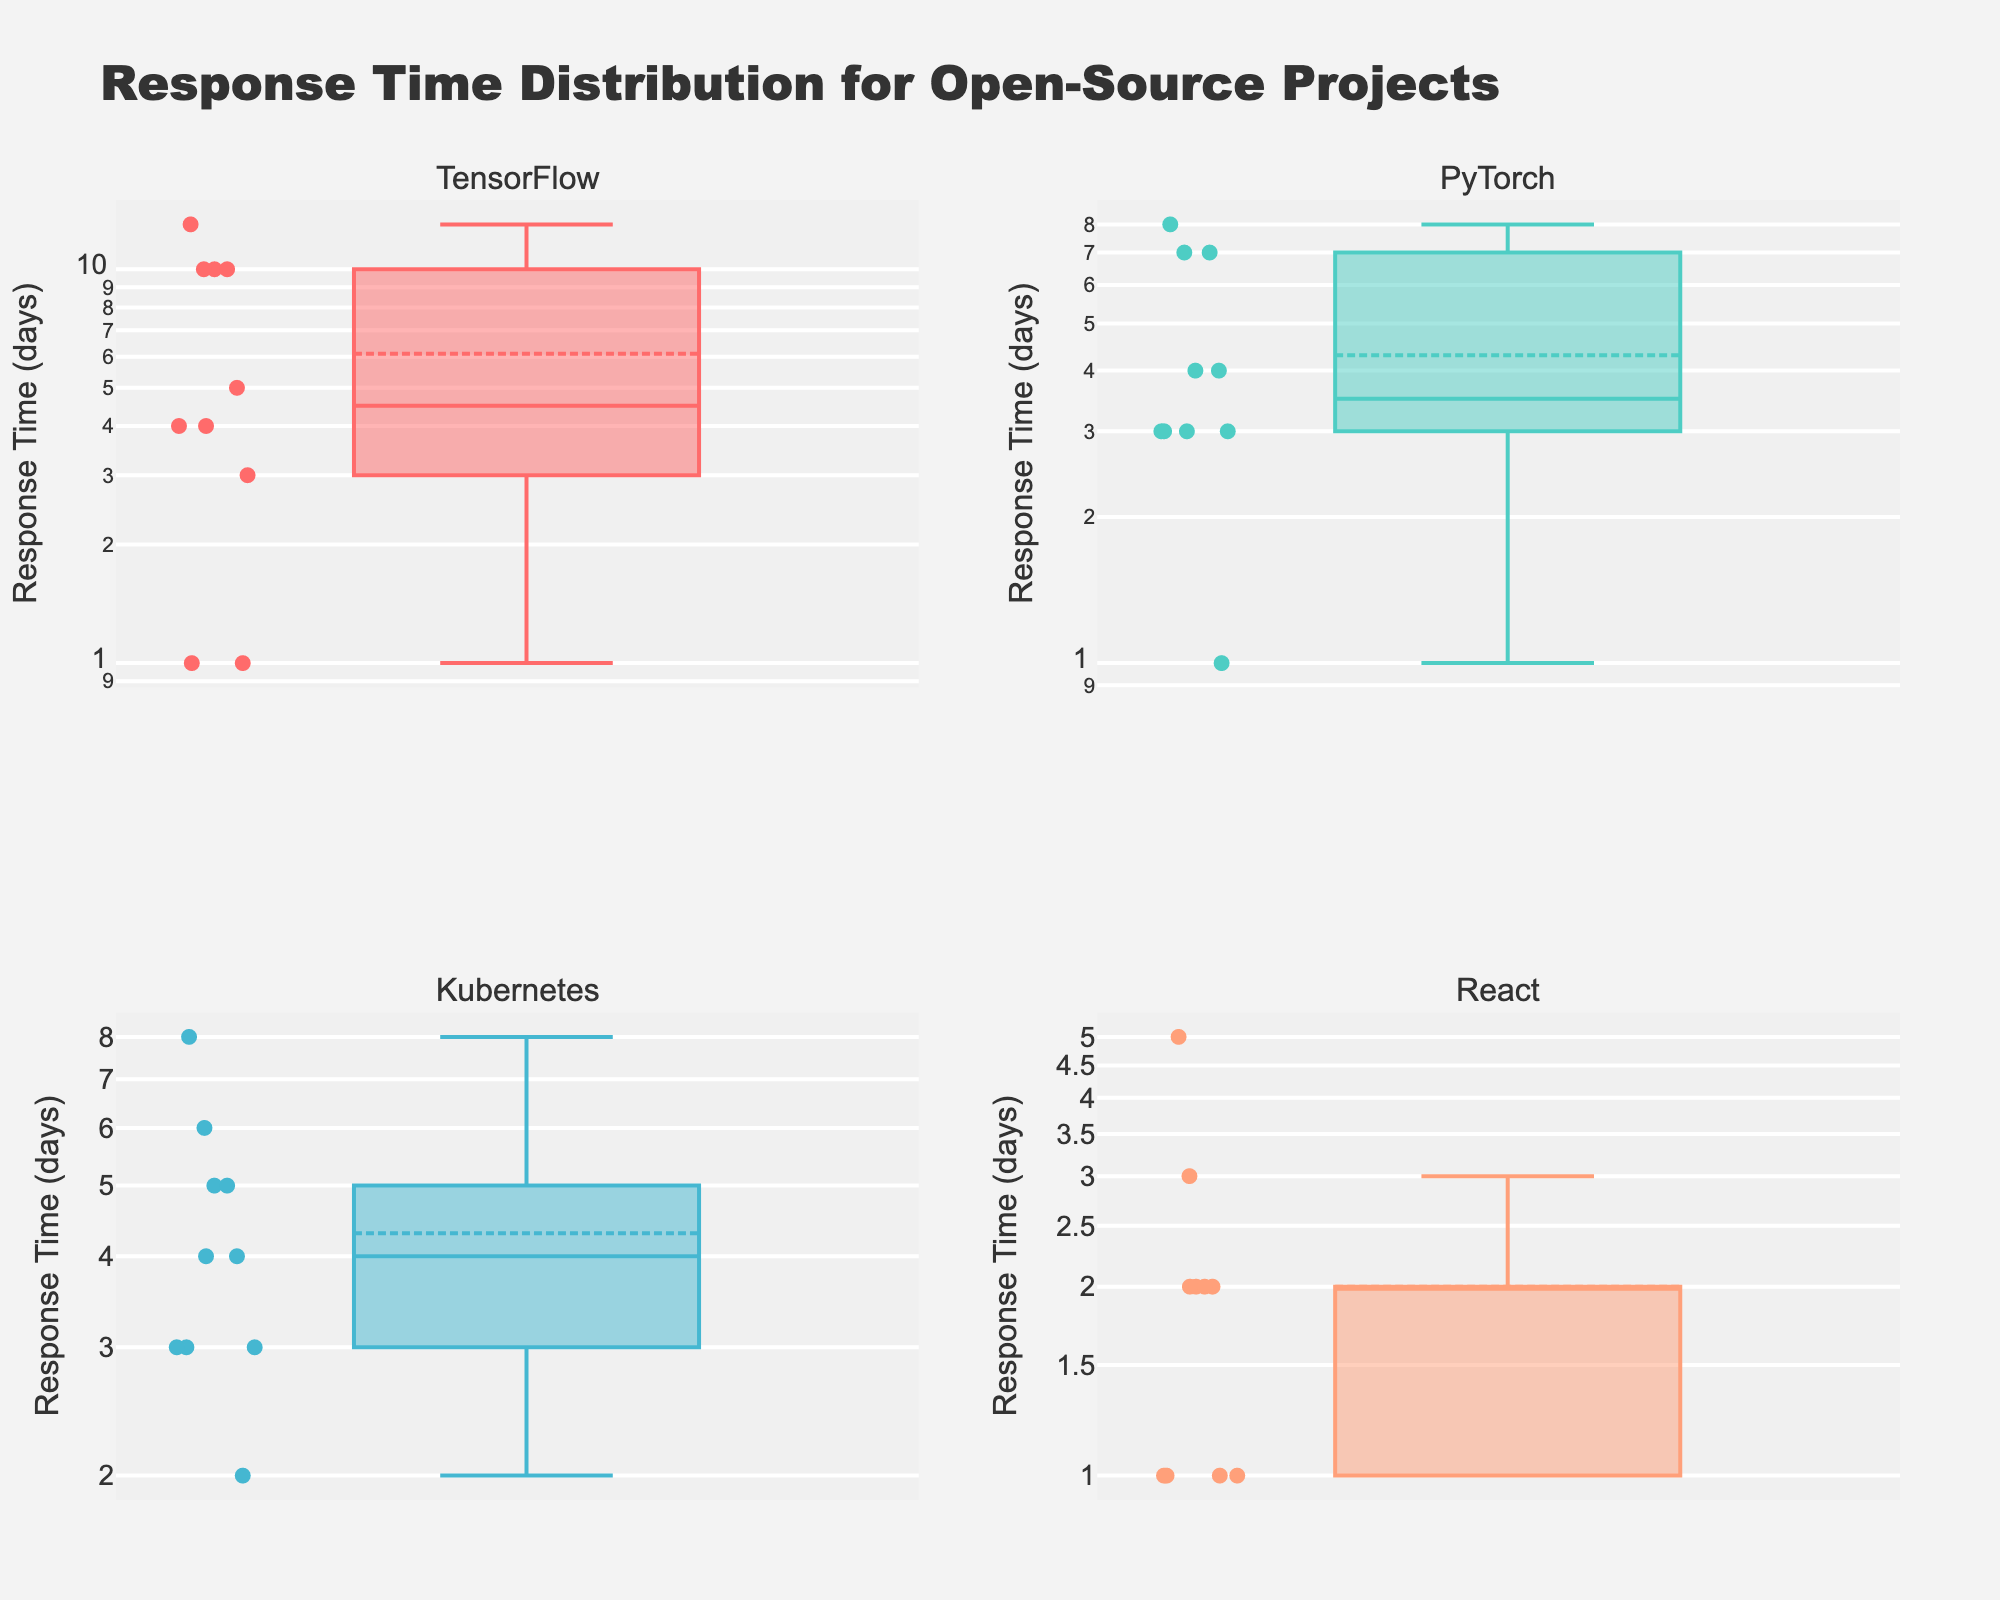Which project has the shortest response time recorded? By observing the y-axis values on the log scale and the box plots themselves, we can see that the shortest response time recorded across all projects is 1 day. TensorFlow, PyTorch, and React all have entries with this response time.
Answer: 1 day Which project has the widest range of response times? The range of response times can be identified by observing the spread between the minimum and maximum values in each box plot. TensorFlow has the widest range, spanning from 1 day to 13 days.
Answer: TensorFlow What is the median response time for PyTorch? The median value is indicated by the line within each box in the box plot. For PyTorch, this line is at the 4-day mark on the y-axis.
Answer: 4 days Which project's response time distribution is mostly below 10 days? By examining the upper whiskers of the box plots, we can determine the distribution. In Kubernetes, the upper whisker stops around the 8-day mark, indicating the distribution is mostly below 10 days.
Answer: Kubernetes How does the median response time of Kubernetes compare to that of TensorFlow? The median values for each project are indicated by the lines inside the boxes. Kubernetes has a median around 4 days, while TensorFlow has a median slightly above 4 days. The median response time of Kubernetes is slightly lower than that of TensorFlow.
Answer: Lower What is the interquartile range of response times for React? The interquartile range (IQR) is the span between the first quartile (Q1) and the third quartile (Q3) inside the box. For React, Q1 is at 1 day, and Q3 is at 2 days, so the IQR is 2 - 1 = 1 day.
Answer: 1 day Which project has the highest median response time? By comparing the medians (the lines inside the boxes), we see that TensorFlow and PyTorch both have medians around 4 days, but TensorFlow's is slightly higher.
Answer: TensorFlow In which project does the maximum response time exceed 10 days? The maximum response time is shown by the highest point of the upper whisker or the highest outlier point in the plot. TensorFlow has response times exceeding 10 days.
Answer: TensorFlow For which project are the outlier response times most common? Outliers are indicated by points outside the whiskers of the box plots. TensorFlow exhibits more outliers compared to the other projects, indicating more variability.
Answer: TensorFlow 